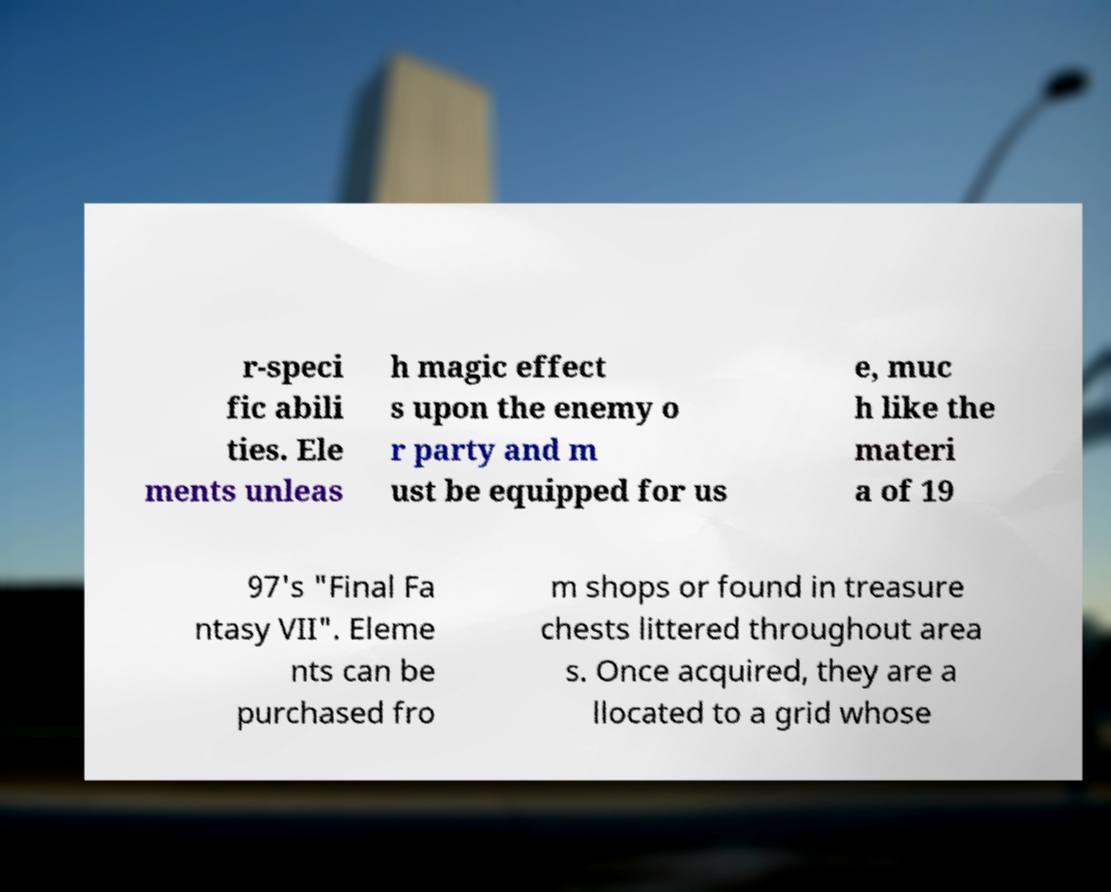Could you extract and type out the text from this image? r-speci fic abili ties. Ele ments unleas h magic effect s upon the enemy o r party and m ust be equipped for us e, muc h like the materi a of 19 97's "Final Fa ntasy VII". Eleme nts can be purchased fro m shops or found in treasure chests littered throughout area s. Once acquired, they are a llocated to a grid whose 